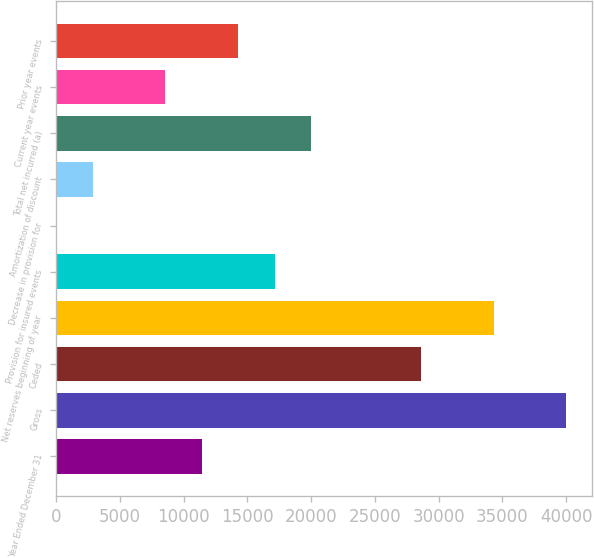Convert chart. <chart><loc_0><loc_0><loc_500><loc_500><bar_chart><fcel>Year Ended December 31<fcel>Gross<fcel>Ceded<fcel>Net reserves beginning of year<fcel>Provision for insured events<fcel>Decrease in provision for<fcel>Amortization of discount<fcel>Total net incurred (a)<fcel>Current year events<fcel>Prior year events<nl><fcel>11438.2<fcel>40021.2<fcel>28588<fcel>34304.6<fcel>17154.8<fcel>5<fcel>2863.3<fcel>20013.1<fcel>8579.9<fcel>14296.5<nl></chart> 